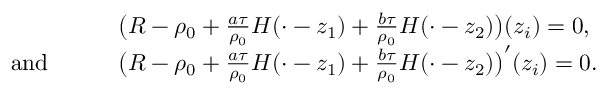Convert formula to latex. <formula><loc_0><loc_0><loc_500><loc_500>\begin{array} { r l } & { \left ( R - \rho _ { 0 } + \frac { a \tau } { \rho _ { 0 } } H ( \cdot - z _ { 1 } ) + \frac { b \tau } { \rho _ { 0 } } H ( \cdot - z _ { 2 } ) \right ) ( z _ { i } ) = 0 , } \\ { a n d \quad } & { \left ( R - \rho _ { 0 } + \frac { a \tau } { \rho _ { 0 } } H ( \cdot - z _ { 1 } ) + \frac { b \tau } { \rho _ { 0 } } H ( \cdot - z _ { 2 } ) \right ) ^ { \prime } ( z _ { i } ) = 0 . } \end{array}</formula> 